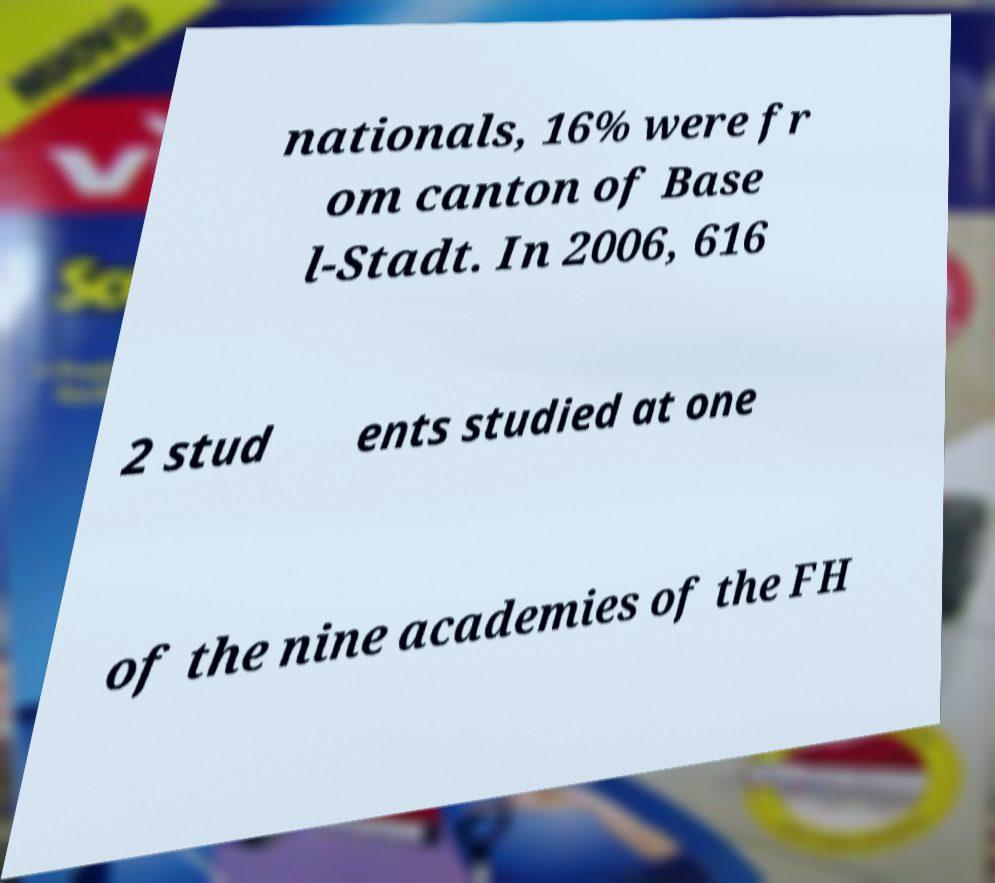Can you accurately transcribe the text from the provided image for me? nationals, 16% were fr om canton of Base l-Stadt. In 2006, 616 2 stud ents studied at one of the nine academies of the FH 